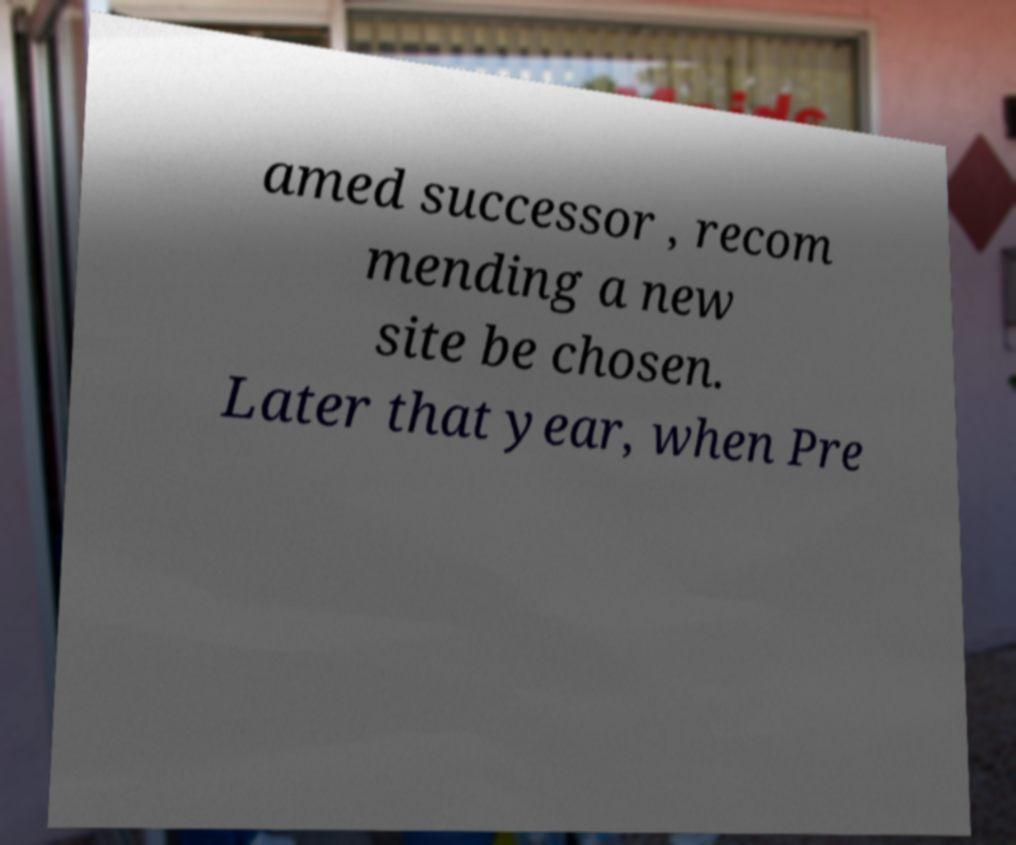There's text embedded in this image that I need extracted. Can you transcribe it verbatim? amed successor , recom mending a new site be chosen. Later that year, when Pre 